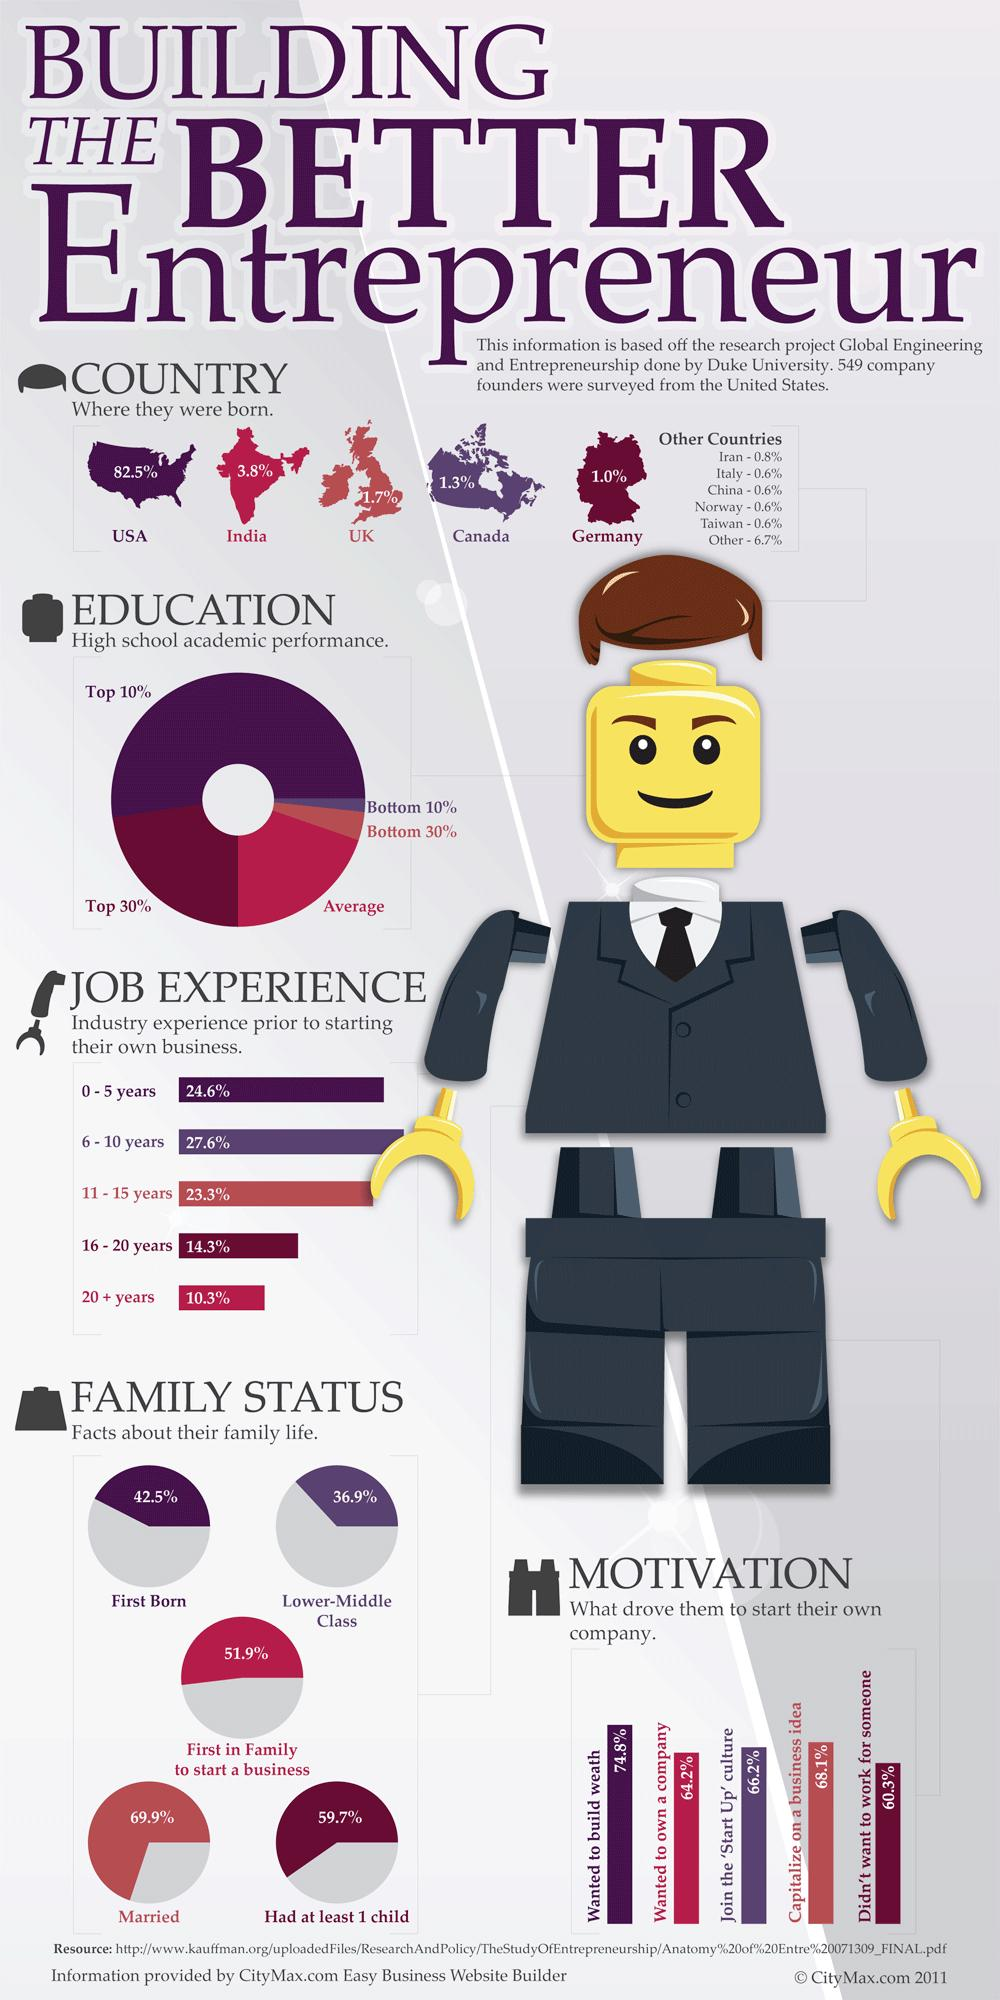Give some essential details in this illustration. According to our survey, 51.9% of the founders we interviewed were the first in their family to start a business. According to a study, 68.1% of founders successfully capitalized on their business idea. Nine point nine percent of the founders in the dataset were born in other countries. In the survey, 24.6% of the founders who responded had over 16 years of job experience. This group included individuals who had been in the workforce for a significant period of time and had accumulated a wealth of knowledge and expertise. According to the data, only 3.8% of founders were born in India. 